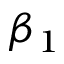Convert formula to latex. <formula><loc_0><loc_0><loc_500><loc_500>\beta _ { 1 }</formula> 